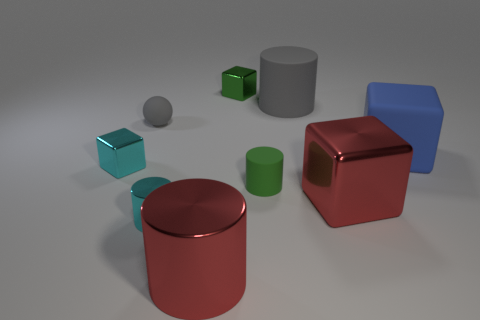Subtract all big red cubes. How many cubes are left? 3 Subtract 1 cubes. How many cubes are left? 3 Add 1 tiny cyan shiny cylinders. How many objects exist? 10 Subtract all green blocks. How many blocks are left? 3 Subtract all spheres. How many objects are left? 8 Add 3 cyan things. How many cyan things are left? 5 Add 1 gray rubber balls. How many gray rubber balls exist? 2 Subtract 0 blue balls. How many objects are left? 9 Subtract all cyan cubes. Subtract all blue cylinders. How many cubes are left? 3 Subtract all big purple metal cubes. Subtract all tiny green metal things. How many objects are left? 8 